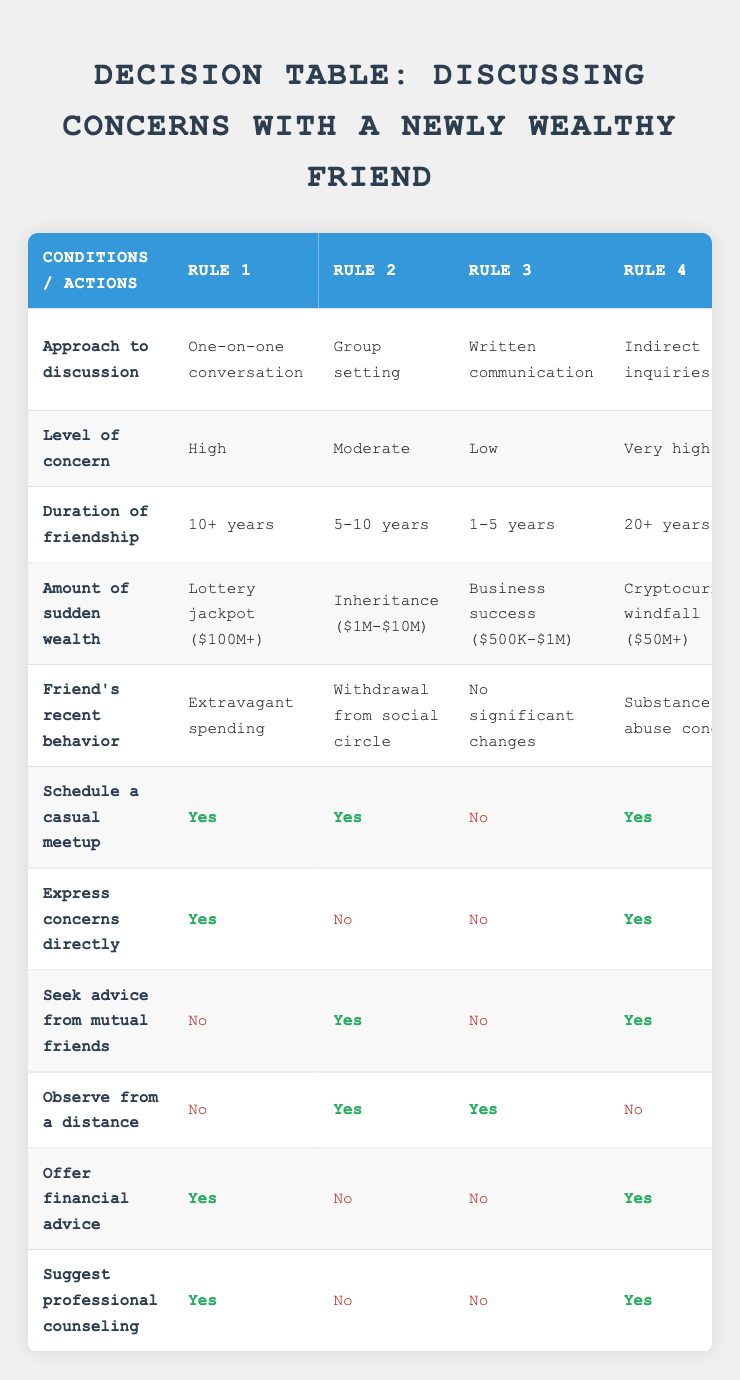What approach to discussion is recommended for a friend with high concern and a friendship duration of over 10 years? To find the approach for a friend with high concern and a friendship duration of over 10 years, look at the first rule in the table. The approach listed is "One-on-one conversation."
Answer: One-on-one conversation Does a friend who has recently experienced a lottery jackpot also require professional counseling according to the table? In the first rule, under the conditions regarding a lottery jackpot and high concern, the recommendation is to "Suggest professional counseling," indicating that it is indeed required.
Answer: Yes Which approaches suggest observing from a distance? To answer this, check which rules have "Observe from a distance" listed as "Yes." This applies to the second rule (group setting) and the third rule (through mutual acquaintances).
Answer: Group setting and through mutual acquaintances For a friend who gained wealth from a business success, is expressing direct concerns appropriate? In the third rule, where the conditions indicate a low level of concern for a friend who gained wealth through business success, the action to express concerns directly is listed as "No."
Answer: No What is the total number of rules where advice from mutual friends is sought? By counting the rules, "Seek advice from mutual friends" is marked as "Yes" in the second rule (group setting), fourth rule (indirect inquiries), and fifth rule (through mutual acquaintances). Thus, the total is three rules.
Answer: 3 What behaviors are associated with friends who have experienced a cryptocurrency windfall and have very high concern? According to the fourth rule, the friend with a cryptocurrency windfall experiencing very high concern has "Substance abuse concerns" as the recent behavior.
Answer: Substance abuse concerns Is offering financial advice recommended for a friend who won a game show and has been very generous? Referring to the fifth rule under the conditions of having won a game show, the recommendation to "Offer financial advice" is marked as "No," hence it is not recommended in this situation.
Answer: No If a discussion is held through mutual acquaintances with a milder concern level, what actions are recommended? Looking at the fifth rule, under this scenario, the actions are to "Schedule a casual meetup," "Seek advice from mutual friends," and "Observe from a distance" are marked as "Yes." Hence, these actions are recommended.
Answer: Schedule a casual meetup, Seek advice from mutual friends, Observe from a distance 